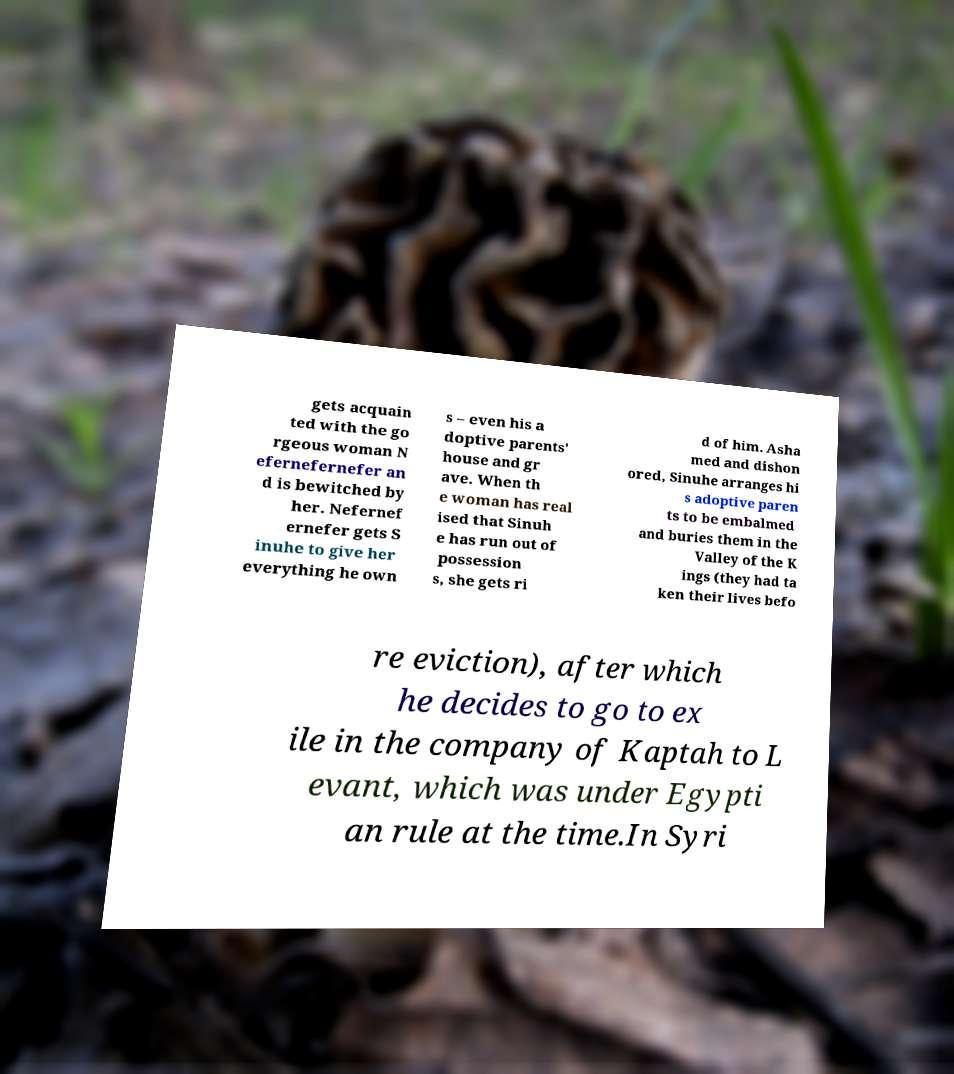What messages or text are displayed in this image? I need them in a readable, typed format. gets acquain ted with the go rgeous woman N efernefernefer an d is bewitched by her. Nefernef ernefer gets S inuhe to give her everything he own s – even his a doptive parents' house and gr ave. When th e woman has real ised that Sinuh e has run out of possession s, she gets ri d of him. Asha med and dishon ored, Sinuhe arranges hi s adoptive paren ts to be embalmed and buries them in the Valley of the K ings (they had ta ken their lives befo re eviction), after which he decides to go to ex ile in the company of Kaptah to L evant, which was under Egypti an rule at the time.In Syri 